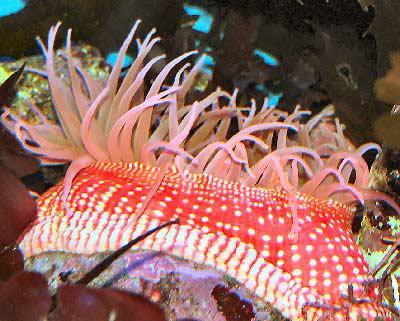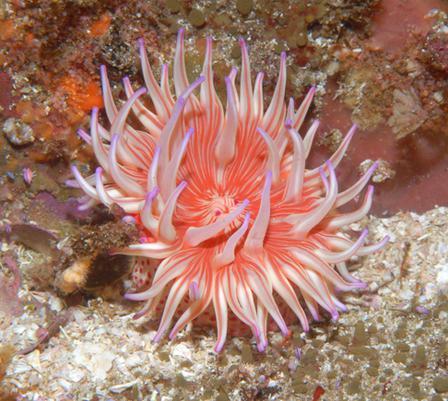The first image is the image on the left, the second image is the image on the right. Given the left and right images, does the statement "Both images contain anemone colored a peachy coral hue." hold true? Answer yes or no. Yes. The first image is the image on the left, the second image is the image on the right. Considering the images on both sides, is "there are two anemones in the image on the left" valid? Answer yes or no. No. 